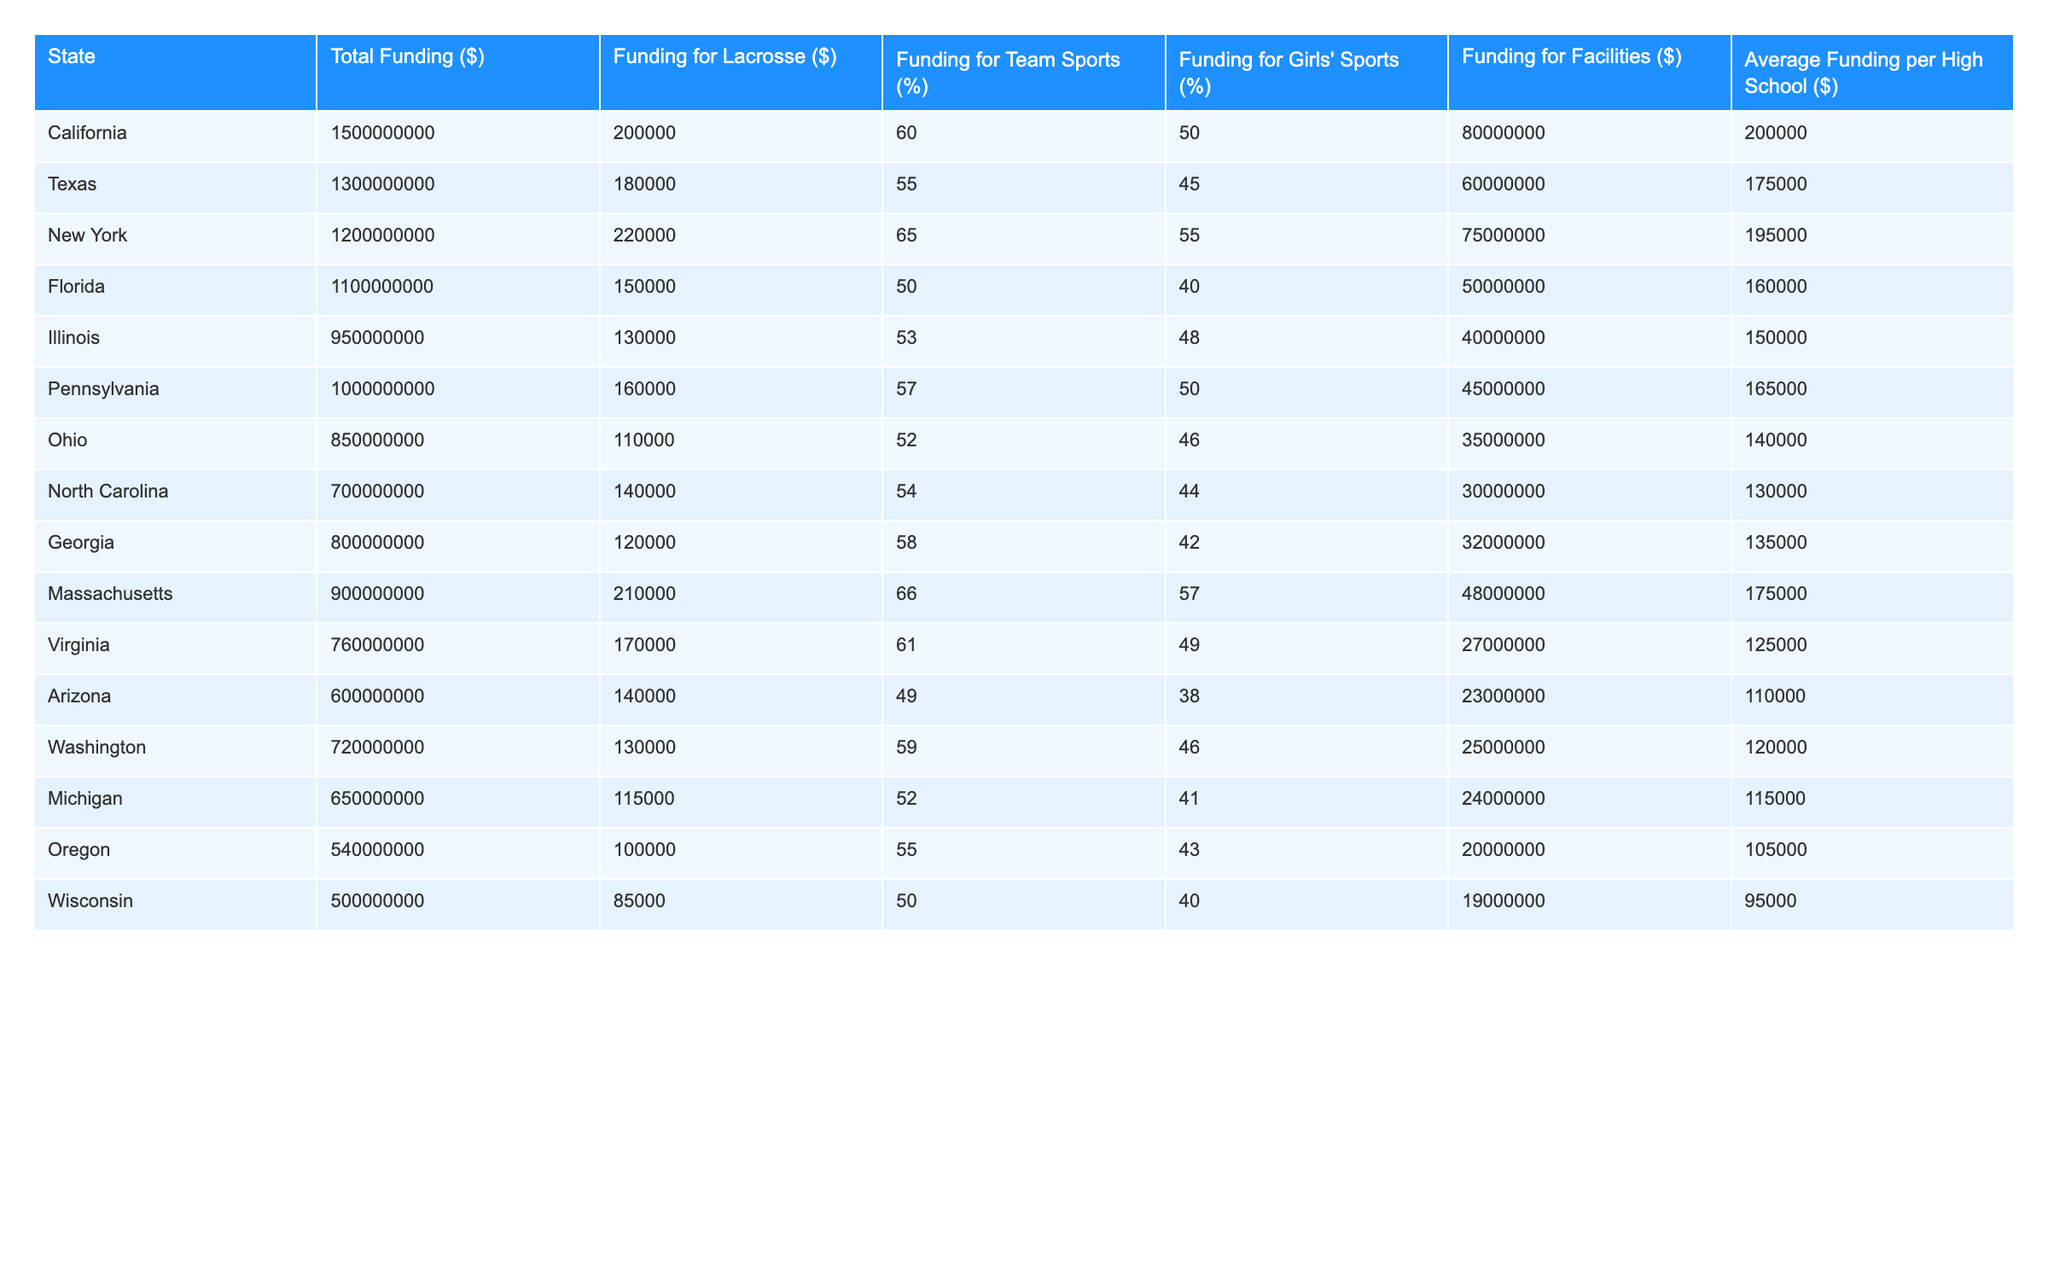What is the total funding for high school sports programs in California? According to the table, California has a total funding of $1,500,000,000 for high school sports programs.
Answer: 1,500,000,000 How much funding is allocated for lacrosse in New York? The table shows that New York allocated $220,000 for lacrosse programs.
Answer: 220,000 Which state has the highest average funding per high school? By comparing the values in the "Average Funding per High School ($)" column, California has the highest average funding of $200,000.
Answer: 200,000 What percentage of funding in Texas is allocated to team sports? The table indicates that Texas allocates 55% of its funding to team sports.
Answer: 55% Which state allocated the least amount of funding for facilities? Examining the "Funding for Facilities ($)" column, Oregon has the least amount of funding, which is $20,000,000.
Answer: 20,000,000 What is the difference in total funding between Florida and Pennsylvania? Florida has a total funding of $1,100,000,000, and Pennsylvania has $1,000,000,000. The difference is $1,100,000,000 - $1,000,000,000 = $100,000,000.
Answer: 100,000,000 Is the funding for girls' sports in Maryland specified in the table? No, there is no entry for Maryland in the table, which means its funding for girls' sports is not specified.
Answer: No Which two states have the same funding amount for lacrosse? Looking at the "Funding for Lacrosse ($)" column, we can see that Ohio and Georgia both allocated $120,000 for lacrosse.
Answer: Ohio and Georgia What percent of total funding in Wisconsin is allocated to girls' sports? Wisconsin allocates 40% of its total funding to girls' sports, as shown in the "Funding for Girls' Sports (%)" column.
Answer: 40% Calculate the average funding for lacrosse across all states. To find the average, we sum the funding for lacrosse: 200,000 + 180,000 + 220,000 + 150,000 + 130,000 + 160,000 + 110,000 + 140,000 + 120,000 + 210,000 + 170,000 + 140,000 + 130,000 + 115,000 + 100,000 + 85,000 = 1,909,000, and then divide by the number of states (16), which is 1,909,000 / 16 = 119,312.5.
Answer: 119,312.5 